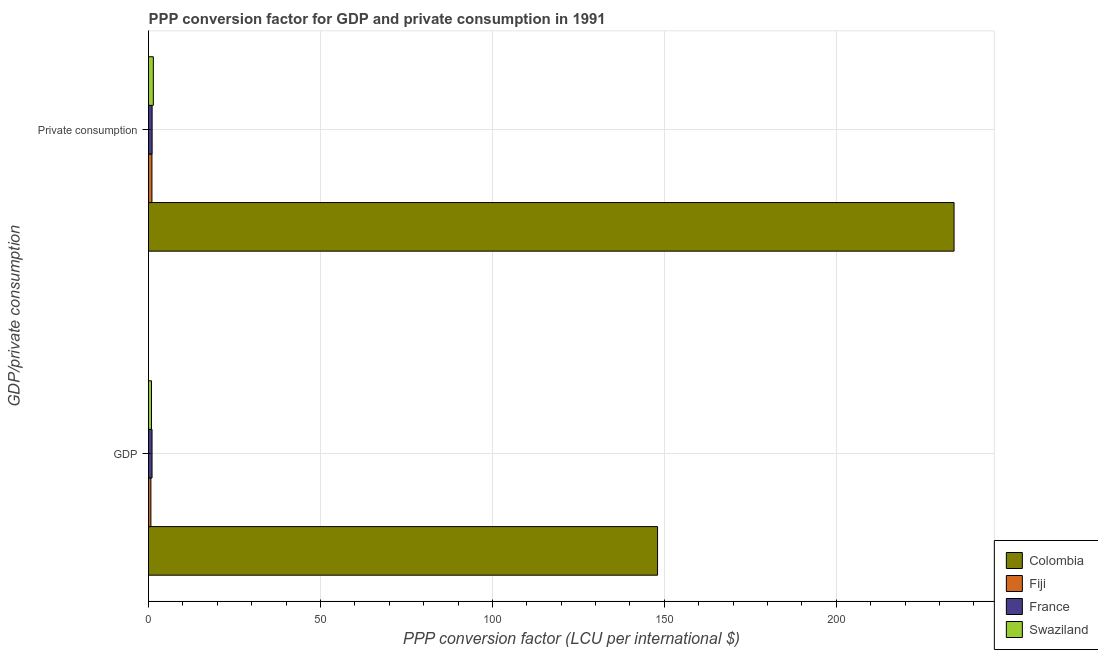How many groups of bars are there?
Offer a very short reply. 2. Are the number of bars per tick equal to the number of legend labels?
Your answer should be very brief. Yes. Are the number of bars on each tick of the Y-axis equal?
Your answer should be compact. Yes. How many bars are there on the 2nd tick from the bottom?
Make the answer very short. 4. What is the label of the 2nd group of bars from the top?
Your answer should be compact. GDP. What is the ppp conversion factor for private consumption in Fiji?
Provide a succinct answer. 1. Across all countries, what is the maximum ppp conversion factor for gdp?
Your answer should be compact. 148.04. Across all countries, what is the minimum ppp conversion factor for gdp?
Provide a short and direct response. 0.69. In which country was the ppp conversion factor for gdp maximum?
Your response must be concise. Colombia. In which country was the ppp conversion factor for private consumption minimum?
Provide a succinct answer. Fiji. What is the total ppp conversion factor for private consumption in the graph?
Provide a succinct answer. 237.71. What is the difference between the ppp conversion factor for gdp in Colombia and that in Fiji?
Keep it short and to the point. 147.34. What is the difference between the ppp conversion factor for private consumption in Swaziland and the ppp conversion factor for gdp in Fiji?
Offer a terse response. 0.71. What is the average ppp conversion factor for gdp per country?
Provide a short and direct response. 37.65. What is the difference between the ppp conversion factor for gdp and ppp conversion factor for private consumption in France?
Offer a very short reply. -0.02. What is the ratio of the ppp conversion factor for gdp in Swaziland to that in Fiji?
Provide a short and direct response. 1.25. Is the ppp conversion factor for gdp in France less than that in Fiji?
Provide a succinct answer. No. What does the 2nd bar from the top in  Private consumption represents?
Give a very brief answer. France. What does the 2nd bar from the bottom in  Private consumption represents?
Your answer should be very brief. Fiji. Are all the bars in the graph horizontal?
Provide a short and direct response. Yes. How many countries are there in the graph?
Provide a short and direct response. 4. What is the difference between two consecutive major ticks on the X-axis?
Make the answer very short. 50. Are the values on the major ticks of X-axis written in scientific E-notation?
Your answer should be compact. No. Does the graph contain any zero values?
Your response must be concise. No. How many legend labels are there?
Ensure brevity in your answer.  4. What is the title of the graph?
Your answer should be compact. PPP conversion factor for GDP and private consumption in 1991. What is the label or title of the X-axis?
Ensure brevity in your answer.  PPP conversion factor (LCU per international $). What is the label or title of the Y-axis?
Your response must be concise. GDP/private consumption. What is the PPP conversion factor (LCU per international $) in Colombia in GDP?
Your answer should be very brief. 148.04. What is the PPP conversion factor (LCU per international $) of Fiji in GDP?
Ensure brevity in your answer.  0.69. What is the PPP conversion factor (LCU per international $) in France in GDP?
Offer a terse response. 1.02. What is the PPP conversion factor (LCU per international $) in Swaziland in GDP?
Offer a terse response. 0.86. What is the PPP conversion factor (LCU per international $) in Colombia in  Private consumption?
Provide a succinct answer. 234.26. What is the PPP conversion factor (LCU per international $) in Fiji in  Private consumption?
Offer a very short reply. 1. What is the PPP conversion factor (LCU per international $) of France in  Private consumption?
Make the answer very short. 1.05. What is the PPP conversion factor (LCU per international $) in Swaziland in  Private consumption?
Give a very brief answer. 1.4. Across all GDP/private consumption, what is the maximum PPP conversion factor (LCU per international $) in Colombia?
Offer a very short reply. 234.26. Across all GDP/private consumption, what is the maximum PPP conversion factor (LCU per international $) in Fiji?
Ensure brevity in your answer.  1. Across all GDP/private consumption, what is the maximum PPP conversion factor (LCU per international $) in France?
Give a very brief answer. 1.05. Across all GDP/private consumption, what is the maximum PPP conversion factor (LCU per international $) in Swaziland?
Ensure brevity in your answer.  1.4. Across all GDP/private consumption, what is the minimum PPP conversion factor (LCU per international $) of Colombia?
Ensure brevity in your answer.  148.04. Across all GDP/private consumption, what is the minimum PPP conversion factor (LCU per international $) of Fiji?
Offer a terse response. 0.69. Across all GDP/private consumption, what is the minimum PPP conversion factor (LCU per international $) in France?
Offer a terse response. 1.02. Across all GDP/private consumption, what is the minimum PPP conversion factor (LCU per international $) of Swaziland?
Your answer should be compact. 0.86. What is the total PPP conversion factor (LCU per international $) of Colombia in the graph?
Your answer should be compact. 382.3. What is the total PPP conversion factor (LCU per international $) in Fiji in the graph?
Give a very brief answer. 1.69. What is the total PPP conversion factor (LCU per international $) of France in the graph?
Give a very brief answer. 2.07. What is the total PPP conversion factor (LCU per international $) of Swaziland in the graph?
Your answer should be compact. 2.27. What is the difference between the PPP conversion factor (LCU per international $) of Colombia in GDP and that in  Private consumption?
Offer a very short reply. -86.23. What is the difference between the PPP conversion factor (LCU per international $) in Fiji in GDP and that in  Private consumption?
Your response must be concise. -0.3. What is the difference between the PPP conversion factor (LCU per international $) of France in GDP and that in  Private consumption?
Your answer should be very brief. -0.03. What is the difference between the PPP conversion factor (LCU per international $) in Swaziland in GDP and that in  Private consumption?
Provide a succinct answer. -0.54. What is the difference between the PPP conversion factor (LCU per international $) in Colombia in GDP and the PPP conversion factor (LCU per international $) in Fiji in  Private consumption?
Give a very brief answer. 147.04. What is the difference between the PPP conversion factor (LCU per international $) of Colombia in GDP and the PPP conversion factor (LCU per international $) of France in  Private consumption?
Offer a terse response. 146.99. What is the difference between the PPP conversion factor (LCU per international $) in Colombia in GDP and the PPP conversion factor (LCU per international $) in Swaziland in  Private consumption?
Your response must be concise. 146.63. What is the difference between the PPP conversion factor (LCU per international $) in Fiji in GDP and the PPP conversion factor (LCU per international $) in France in  Private consumption?
Make the answer very short. -0.36. What is the difference between the PPP conversion factor (LCU per international $) in Fiji in GDP and the PPP conversion factor (LCU per international $) in Swaziland in  Private consumption?
Offer a terse response. -0.71. What is the difference between the PPP conversion factor (LCU per international $) of France in GDP and the PPP conversion factor (LCU per international $) of Swaziland in  Private consumption?
Offer a very short reply. -0.38. What is the average PPP conversion factor (LCU per international $) in Colombia per GDP/private consumption?
Provide a short and direct response. 191.15. What is the average PPP conversion factor (LCU per international $) of Fiji per GDP/private consumption?
Your answer should be compact. 0.84. What is the average PPP conversion factor (LCU per international $) of France per GDP/private consumption?
Give a very brief answer. 1.04. What is the average PPP conversion factor (LCU per international $) in Swaziland per GDP/private consumption?
Keep it short and to the point. 1.13. What is the difference between the PPP conversion factor (LCU per international $) of Colombia and PPP conversion factor (LCU per international $) of Fiji in GDP?
Provide a short and direct response. 147.34. What is the difference between the PPP conversion factor (LCU per international $) in Colombia and PPP conversion factor (LCU per international $) in France in GDP?
Keep it short and to the point. 147.01. What is the difference between the PPP conversion factor (LCU per international $) of Colombia and PPP conversion factor (LCU per international $) of Swaziland in GDP?
Provide a succinct answer. 147.17. What is the difference between the PPP conversion factor (LCU per international $) in Fiji and PPP conversion factor (LCU per international $) in France in GDP?
Offer a terse response. -0.33. What is the difference between the PPP conversion factor (LCU per international $) in Fiji and PPP conversion factor (LCU per international $) in Swaziland in GDP?
Give a very brief answer. -0.17. What is the difference between the PPP conversion factor (LCU per international $) in France and PPP conversion factor (LCU per international $) in Swaziland in GDP?
Provide a short and direct response. 0.16. What is the difference between the PPP conversion factor (LCU per international $) in Colombia and PPP conversion factor (LCU per international $) in Fiji in  Private consumption?
Provide a succinct answer. 233.27. What is the difference between the PPP conversion factor (LCU per international $) of Colombia and PPP conversion factor (LCU per international $) of France in  Private consumption?
Offer a very short reply. 233.21. What is the difference between the PPP conversion factor (LCU per international $) of Colombia and PPP conversion factor (LCU per international $) of Swaziland in  Private consumption?
Your answer should be very brief. 232.86. What is the difference between the PPP conversion factor (LCU per international $) in Fiji and PPP conversion factor (LCU per international $) in France in  Private consumption?
Your answer should be compact. -0.05. What is the difference between the PPP conversion factor (LCU per international $) of Fiji and PPP conversion factor (LCU per international $) of Swaziland in  Private consumption?
Your response must be concise. -0.41. What is the difference between the PPP conversion factor (LCU per international $) in France and PPP conversion factor (LCU per international $) in Swaziland in  Private consumption?
Your answer should be compact. -0.35. What is the ratio of the PPP conversion factor (LCU per international $) in Colombia in GDP to that in  Private consumption?
Provide a succinct answer. 0.63. What is the ratio of the PPP conversion factor (LCU per international $) of Fiji in GDP to that in  Private consumption?
Keep it short and to the point. 0.69. What is the ratio of the PPP conversion factor (LCU per international $) of France in GDP to that in  Private consumption?
Make the answer very short. 0.98. What is the ratio of the PPP conversion factor (LCU per international $) in Swaziland in GDP to that in  Private consumption?
Provide a succinct answer. 0.61. What is the difference between the highest and the second highest PPP conversion factor (LCU per international $) in Colombia?
Your response must be concise. 86.23. What is the difference between the highest and the second highest PPP conversion factor (LCU per international $) in Fiji?
Ensure brevity in your answer.  0.3. What is the difference between the highest and the second highest PPP conversion factor (LCU per international $) in France?
Ensure brevity in your answer.  0.03. What is the difference between the highest and the second highest PPP conversion factor (LCU per international $) of Swaziland?
Keep it short and to the point. 0.54. What is the difference between the highest and the lowest PPP conversion factor (LCU per international $) in Colombia?
Ensure brevity in your answer.  86.23. What is the difference between the highest and the lowest PPP conversion factor (LCU per international $) in Fiji?
Keep it short and to the point. 0.3. What is the difference between the highest and the lowest PPP conversion factor (LCU per international $) of France?
Ensure brevity in your answer.  0.03. What is the difference between the highest and the lowest PPP conversion factor (LCU per international $) in Swaziland?
Offer a very short reply. 0.54. 